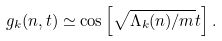<formula> <loc_0><loc_0><loc_500><loc_500>g _ { k } ( n , t ) \simeq \cos \left [ \sqrt { \Lambda _ { k } ( n ) / m } t \right ] .</formula> 